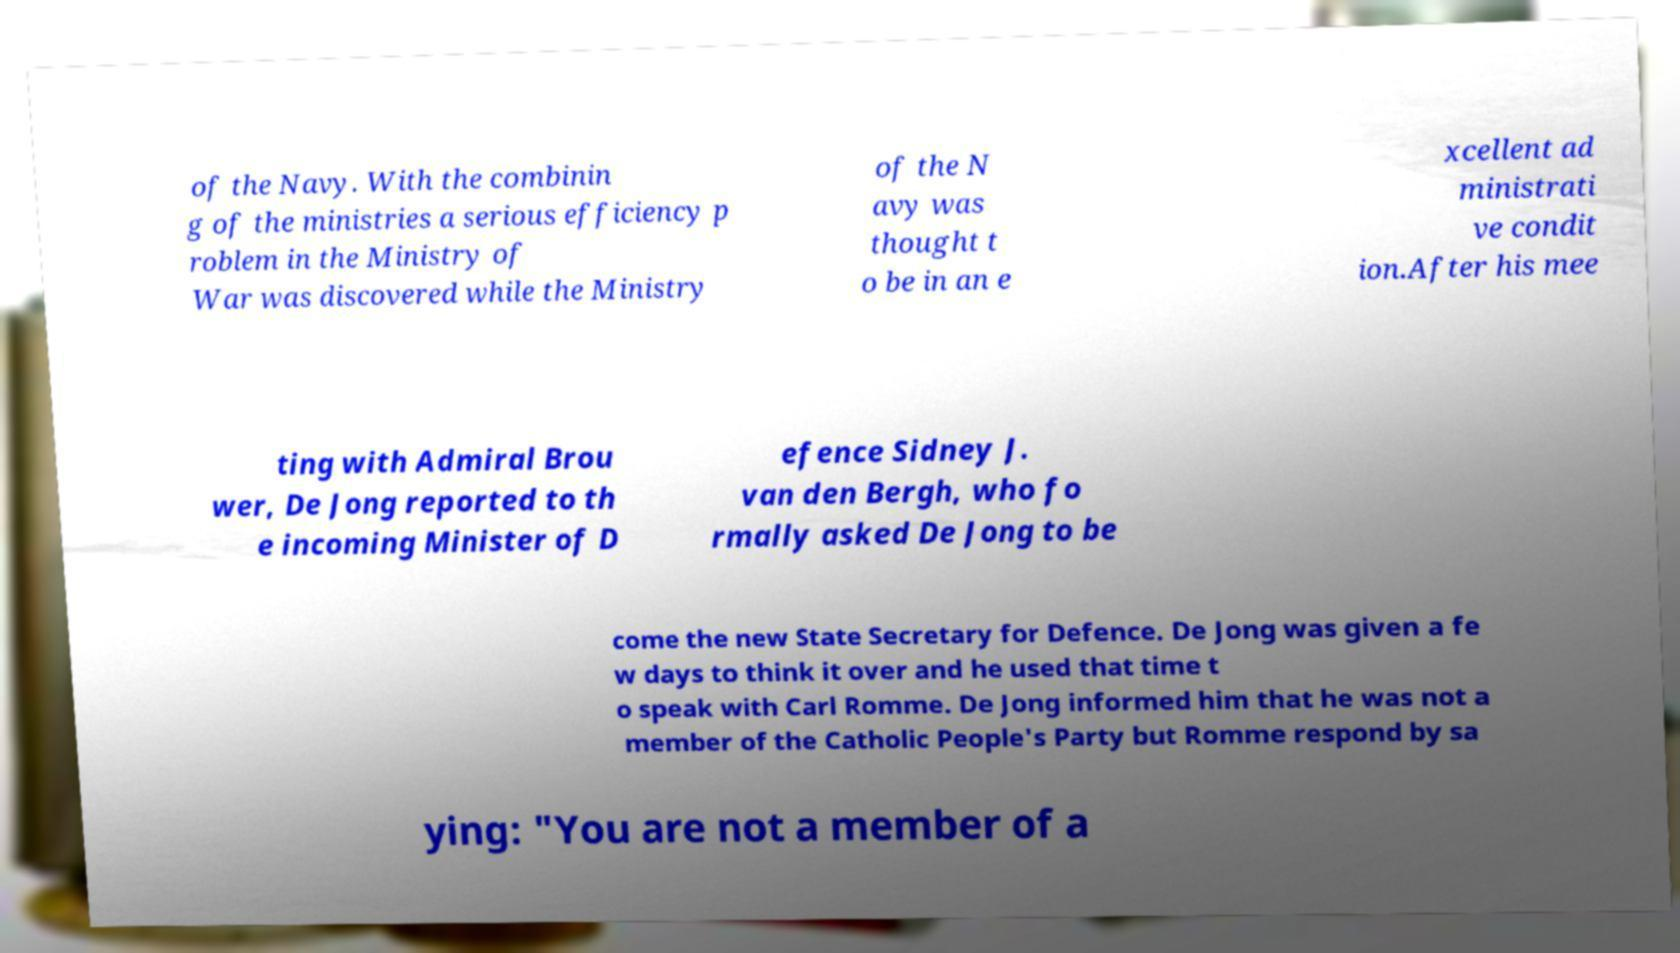Can you accurately transcribe the text from the provided image for me? of the Navy. With the combinin g of the ministries a serious efficiency p roblem in the Ministry of War was discovered while the Ministry of the N avy was thought t o be in an e xcellent ad ministrati ve condit ion.After his mee ting with Admiral Brou wer, De Jong reported to th e incoming Minister of D efence Sidney J. van den Bergh, who fo rmally asked De Jong to be come the new State Secretary for Defence. De Jong was given a fe w days to think it over and he used that time t o speak with Carl Romme. De Jong informed him that he was not a member of the Catholic People's Party but Romme respond by sa ying: "You are not a member of a 